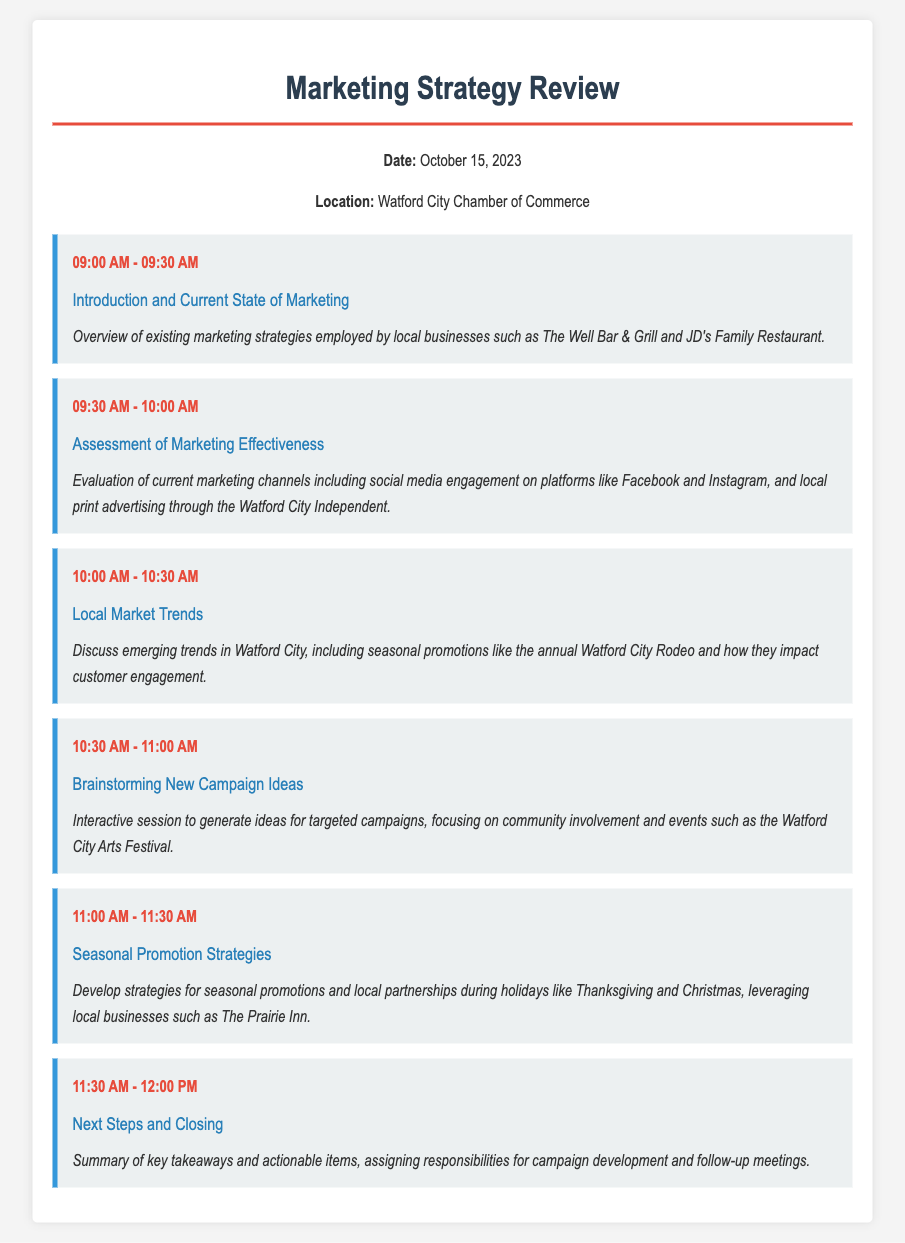What is the date of the meeting? The date of the meeting is clearly stated in the document.
Answer: October 15, 2023 What is the location of the meeting? The location of the meeting is mentioned in the header information.
Answer: Watford City Chamber of Commerce What time does the brainstorming session start? The time for the brainstorming session is given in the agenda.
Answer: 10:30 AM Which local businesses are mentioned in the introduction? The introduction states specific local businesses that will be discussed.
Answer: The Well Bar & Grill and JD's Family Restaurant What key event is referenced in the local market trends section? The document mentions a specific annual event impacting customer engagement in Watford City.
Answer: Watford City Rodeo How long is the assessment of marketing effectiveness scheduled to last? The duration for the assessment section is provided in the agenda.
Answer: 30 minutes What type of session is included for generating new ideas? The format of the session for new campaign ideas is described in the agenda item.
Answer: Interactive session Which local business is mentioned for seasonal promotion during Thanksgiving? The document identifies a local business to leverage for holiday promotions.
Answer: The Prairie Inn What is the purpose of the closing section? The closing section describes the intent behind summarizing the meeting outcomes.
Answer: Summary of key takeaways and actionable items 